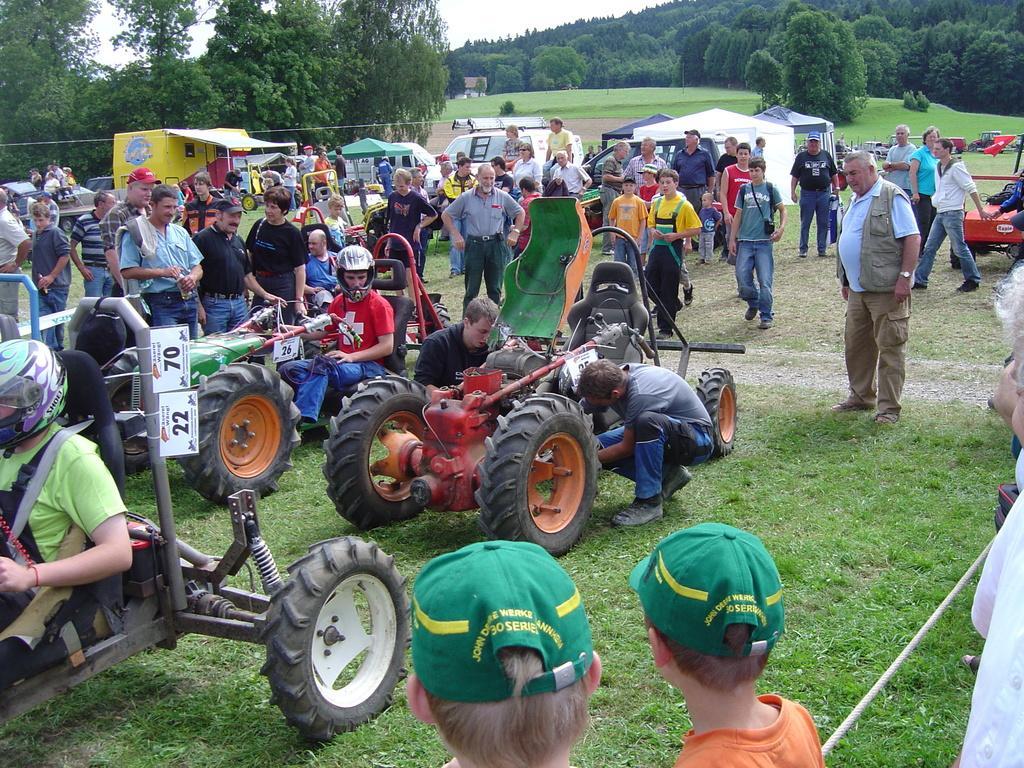Could you give a brief overview of what you see in this image? In this picture I can see a number of vehicles on the surface. I can see green grass. I can see trees. I can see a few people standing on the surface. 